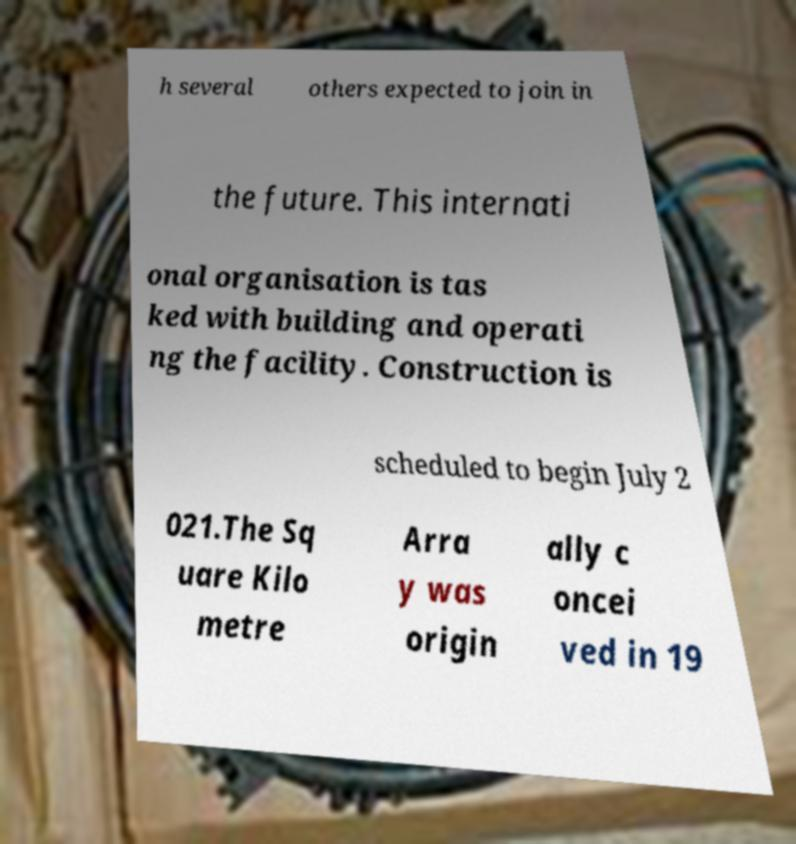Could you assist in decoding the text presented in this image and type it out clearly? h several others expected to join in the future. This internati onal organisation is tas ked with building and operati ng the facility. Construction is scheduled to begin July 2 021.The Sq uare Kilo metre Arra y was origin ally c oncei ved in 19 